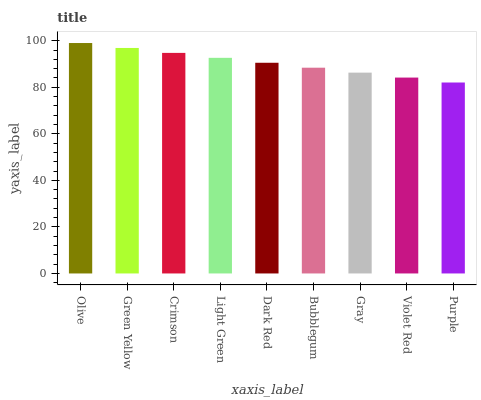Is Purple the minimum?
Answer yes or no. Yes. Is Olive the maximum?
Answer yes or no. Yes. Is Green Yellow the minimum?
Answer yes or no. No. Is Green Yellow the maximum?
Answer yes or no. No. Is Olive greater than Green Yellow?
Answer yes or no. Yes. Is Green Yellow less than Olive?
Answer yes or no. Yes. Is Green Yellow greater than Olive?
Answer yes or no. No. Is Olive less than Green Yellow?
Answer yes or no. No. Is Dark Red the high median?
Answer yes or no. Yes. Is Dark Red the low median?
Answer yes or no. Yes. Is Light Green the high median?
Answer yes or no. No. Is Olive the low median?
Answer yes or no. No. 